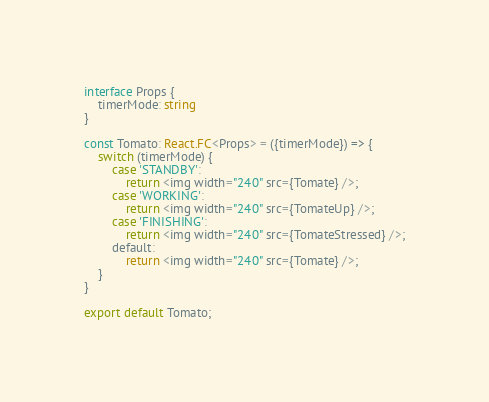Convert code to text. <code><loc_0><loc_0><loc_500><loc_500><_TypeScript_>interface Props {
    timerMode: string
}

const Tomato: React.FC<Props> = ({timerMode}) => {
    switch (timerMode) {
        case 'STANDBY':
            return <img width="240" src={Tomate} />;
        case 'WORKING':
            return <img width="240" src={TomateUp} />;
        case 'FINISHING':
            return <img width="240" src={TomateStressed} />;
        default:
            return <img width="240" src={Tomate} />;
    }
}

export default Tomato;
</code> 